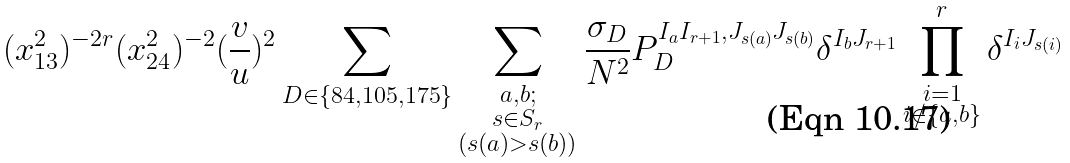Convert formula to latex. <formula><loc_0><loc_0><loc_500><loc_500>( x _ { 1 3 } ^ { 2 } ) ^ { - 2 r } ( x _ { 2 4 } ^ { 2 } ) ^ { - 2 } ( \frac { v } { u } ) ^ { 2 } \sum _ { D \in \{ { 8 4 } , { 1 0 5 } , { 1 7 5 } \} } \sum _ { \substack { a , b ; \\ s \in S _ { r } \\ ( s ( a ) > s ( b ) ) } } \frac { \sigma _ { D } } { N ^ { 2 } } P _ { D } ^ { I _ { a } I _ { r + 1 } , J _ { s ( a ) } J _ { s ( b ) } } \delta ^ { I _ { b } J _ { r + 1 } } \prod ^ { r } _ { \substack { i = 1 \\ i \notin \{ a , b \} } } \delta ^ { I _ { i } J _ { s ( i ) } }</formula> 